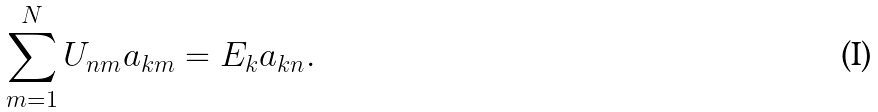Convert formula to latex. <formula><loc_0><loc_0><loc_500><loc_500>\sum _ { m = 1 } ^ { N } U _ { n m } a _ { k m } = E _ { k } a _ { k n } .</formula> 